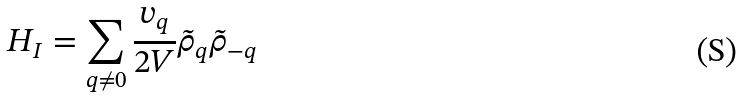Convert formula to latex. <formula><loc_0><loc_0><loc_500><loc_500>H _ { I } = \sum _ { { q } \neq 0 } \frac { v _ { q } } { 2 V } { \tilde { \rho } } _ { q } { \tilde { \rho } } _ { - { q } }</formula> 